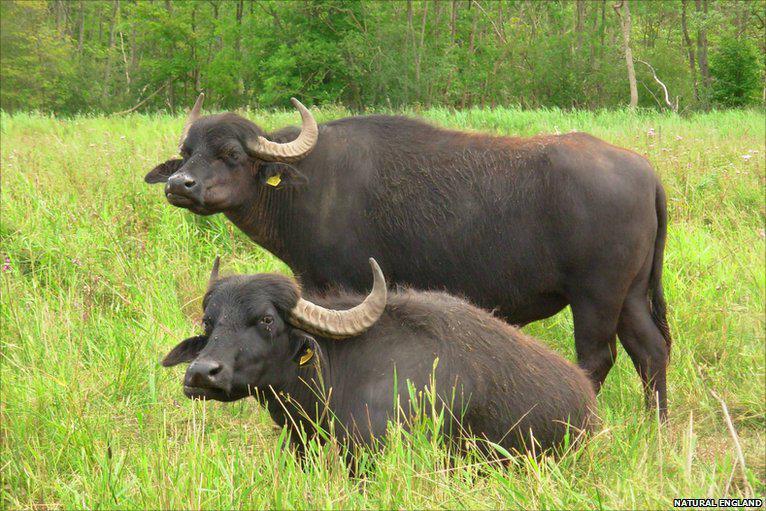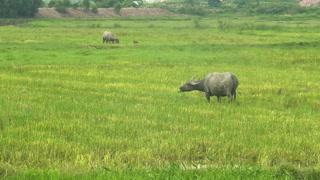The first image is the image on the left, the second image is the image on the right. Given the left and right images, does the statement "One image shows at least two water buffalo in water up to their chins." hold true? Answer yes or no. No. The first image is the image on the left, the second image is the image on the right. For the images displayed, is the sentence "The left image contains exactly two water buffaloes." factually correct? Answer yes or no. Yes. 